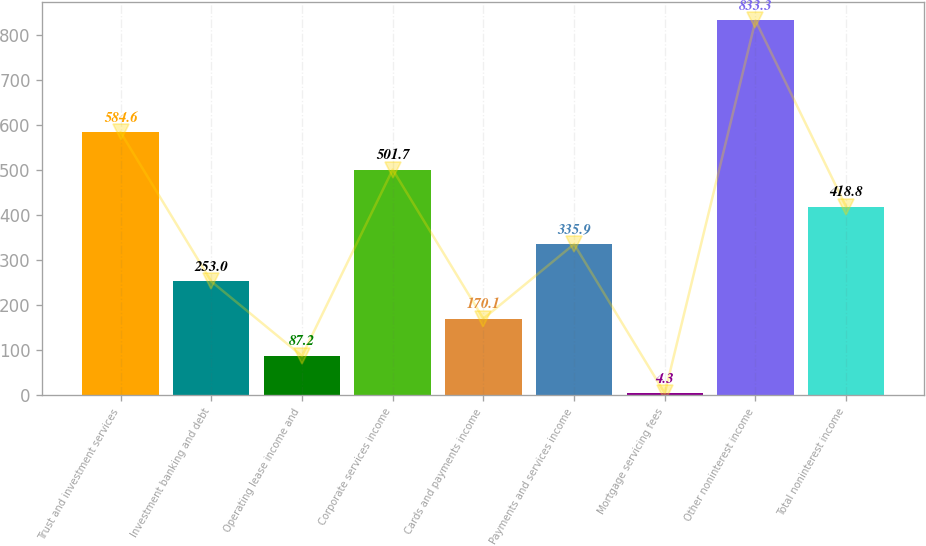Convert chart to OTSL. <chart><loc_0><loc_0><loc_500><loc_500><bar_chart><fcel>Trust and investment services<fcel>Investment banking and debt<fcel>Operating lease income and<fcel>Corporate services income<fcel>Cards and payments income<fcel>Payments and services income<fcel>Mortgage servicing fees<fcel>Other noninterest income<fcel>Total noninterest income<nl><fcel>584.6<fcel>253<fcel>87.2<fcel>501.7<fcel>170.1<fcel>335.9<fcel>4.3<fcel>833.3<fcel>418.8<nl></chart> 